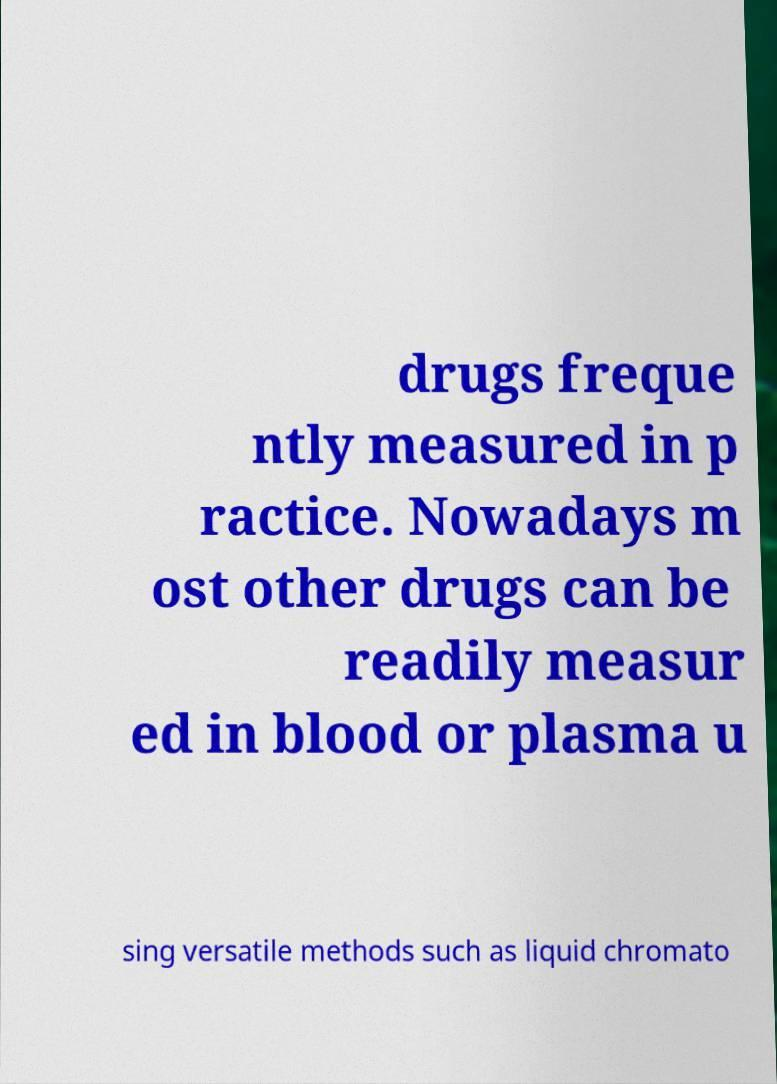Please read and relay the text visible in this image. What does it say? drugs freque ntly measured in p ractice. Nowadays m ost other drugs can be readily measur ed in blood or plasma u sing versatile methods such as liquid chromato 